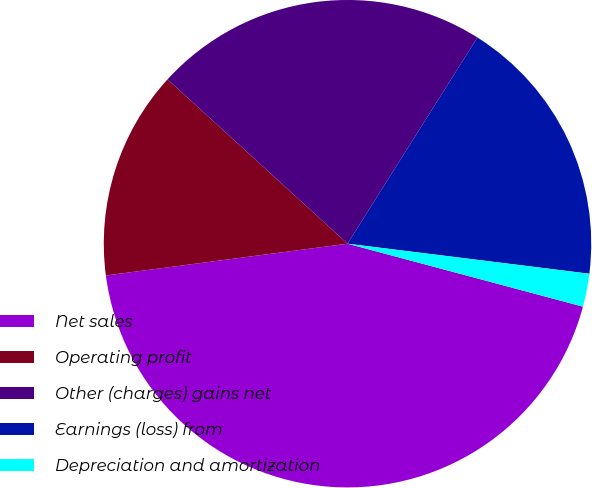Convert chart. <chart><loc_0><loc_0><loc_500><loc_500><pie_chart><fcel>Net sales<fcel>Operating profit<fcel>Other (charges) gains net<fcel>Earnings (loss) from<fcel>Depreciation and amortization<nl><fcel>43.76%<fcel>13.86%<fcel>22.17%<fcel>18.02%<fcel>2.19%<nl></chart> 